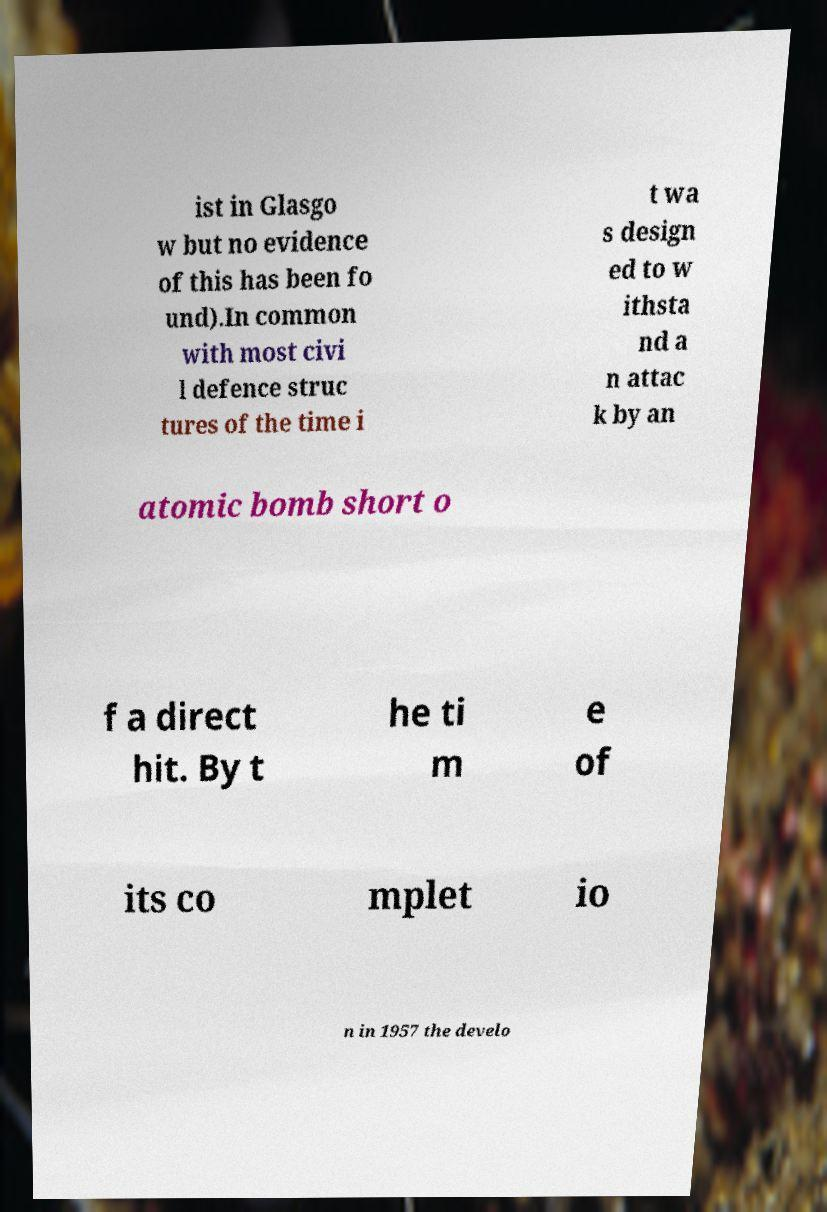Please read and relay the text visible in this image. What does it say? ist in Glasgo w but no evidence of this has been fo und).In common with most civi l defence struc tures of the time i t wa s design ed to w ithsta nd a n attac k by an atomic bomb short o f a direct hit. By t he ti m e of its co mplet io n in 1957 the develo 